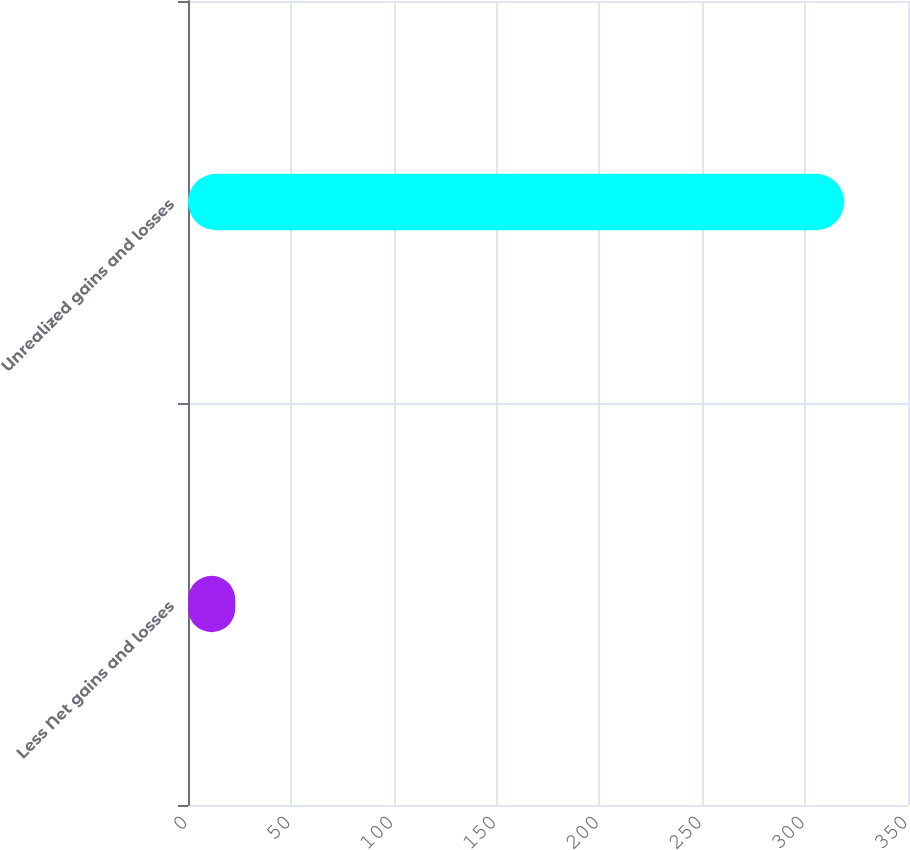Convert chart to OTSL. <chart><loc_0><loc_0><loc_500><loc_500><bar_chart><fcel>Less Net gains and losses<fcel>Unrealized gains and losses<nl><fcel>23<fcel>319<nl></chart> 